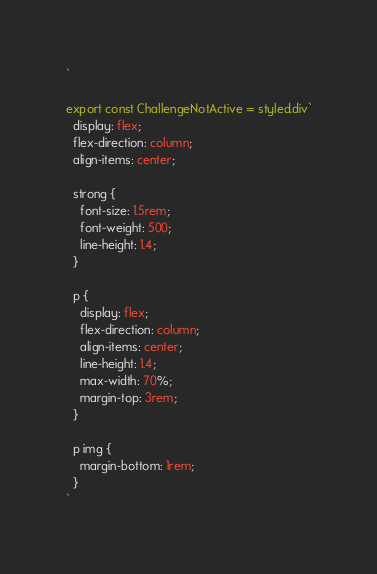<code> <loc_0><loc_0><loc_500><loc_500><_TypeScript_>`

export const ChallengeNotActive = styled.div`
  display: flex;
  flex-direction: column;
  align-items: center;

  strong {
    font-size: 1.5rem;
    font-weight: 500;
    line-height: 1.4;
  }

  p {
    display: flex;
    flex-direction: column;
    align-items: center;
    line-height: 1.4;
    max-width: 70%;
    margin-top: 3rem;
  }

  p img {
    margin-bottom: 1rem;
  }
`
</code> 